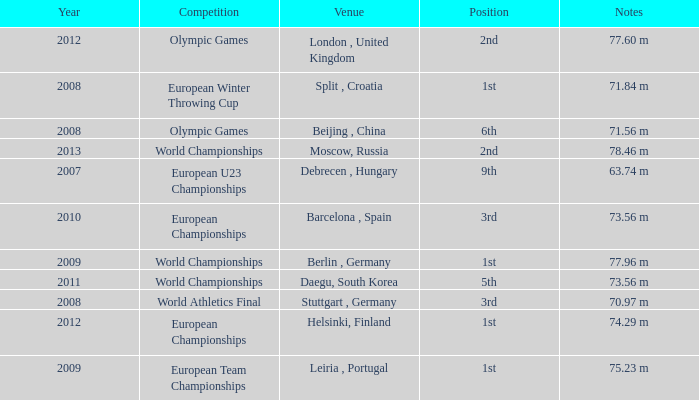Which Notes have a Competition of world championships, and a Position of 2nd? 78.46 m. 